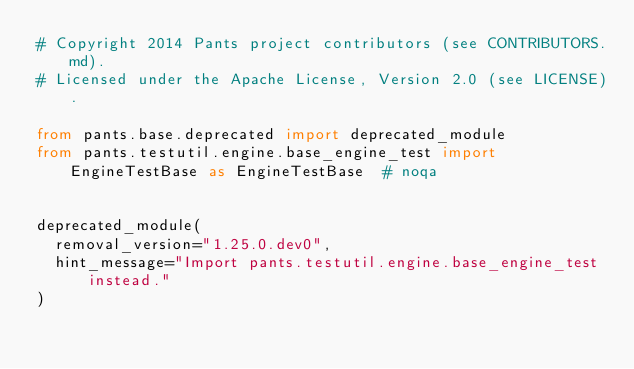Convert code to text. <code><loc_0><loc_0><loc_500><loc_500><_Python_># Copyright 2014 Pants project contributors (see CONTRIBUTORS.md).
# Licensed under the Apache License, Version 2.0 (see LICENSE).

from pants.base.deprecated import deprecated_module
from pants.testutil.engine.base_engine_test import EngineTestBase as EngineTestBase  # noqa


deprecated_module(
  removal_version="1.25.0.dev0",
  hint_message="Import pants.testutil.engine.base_engine_test instead."
)
</code> 